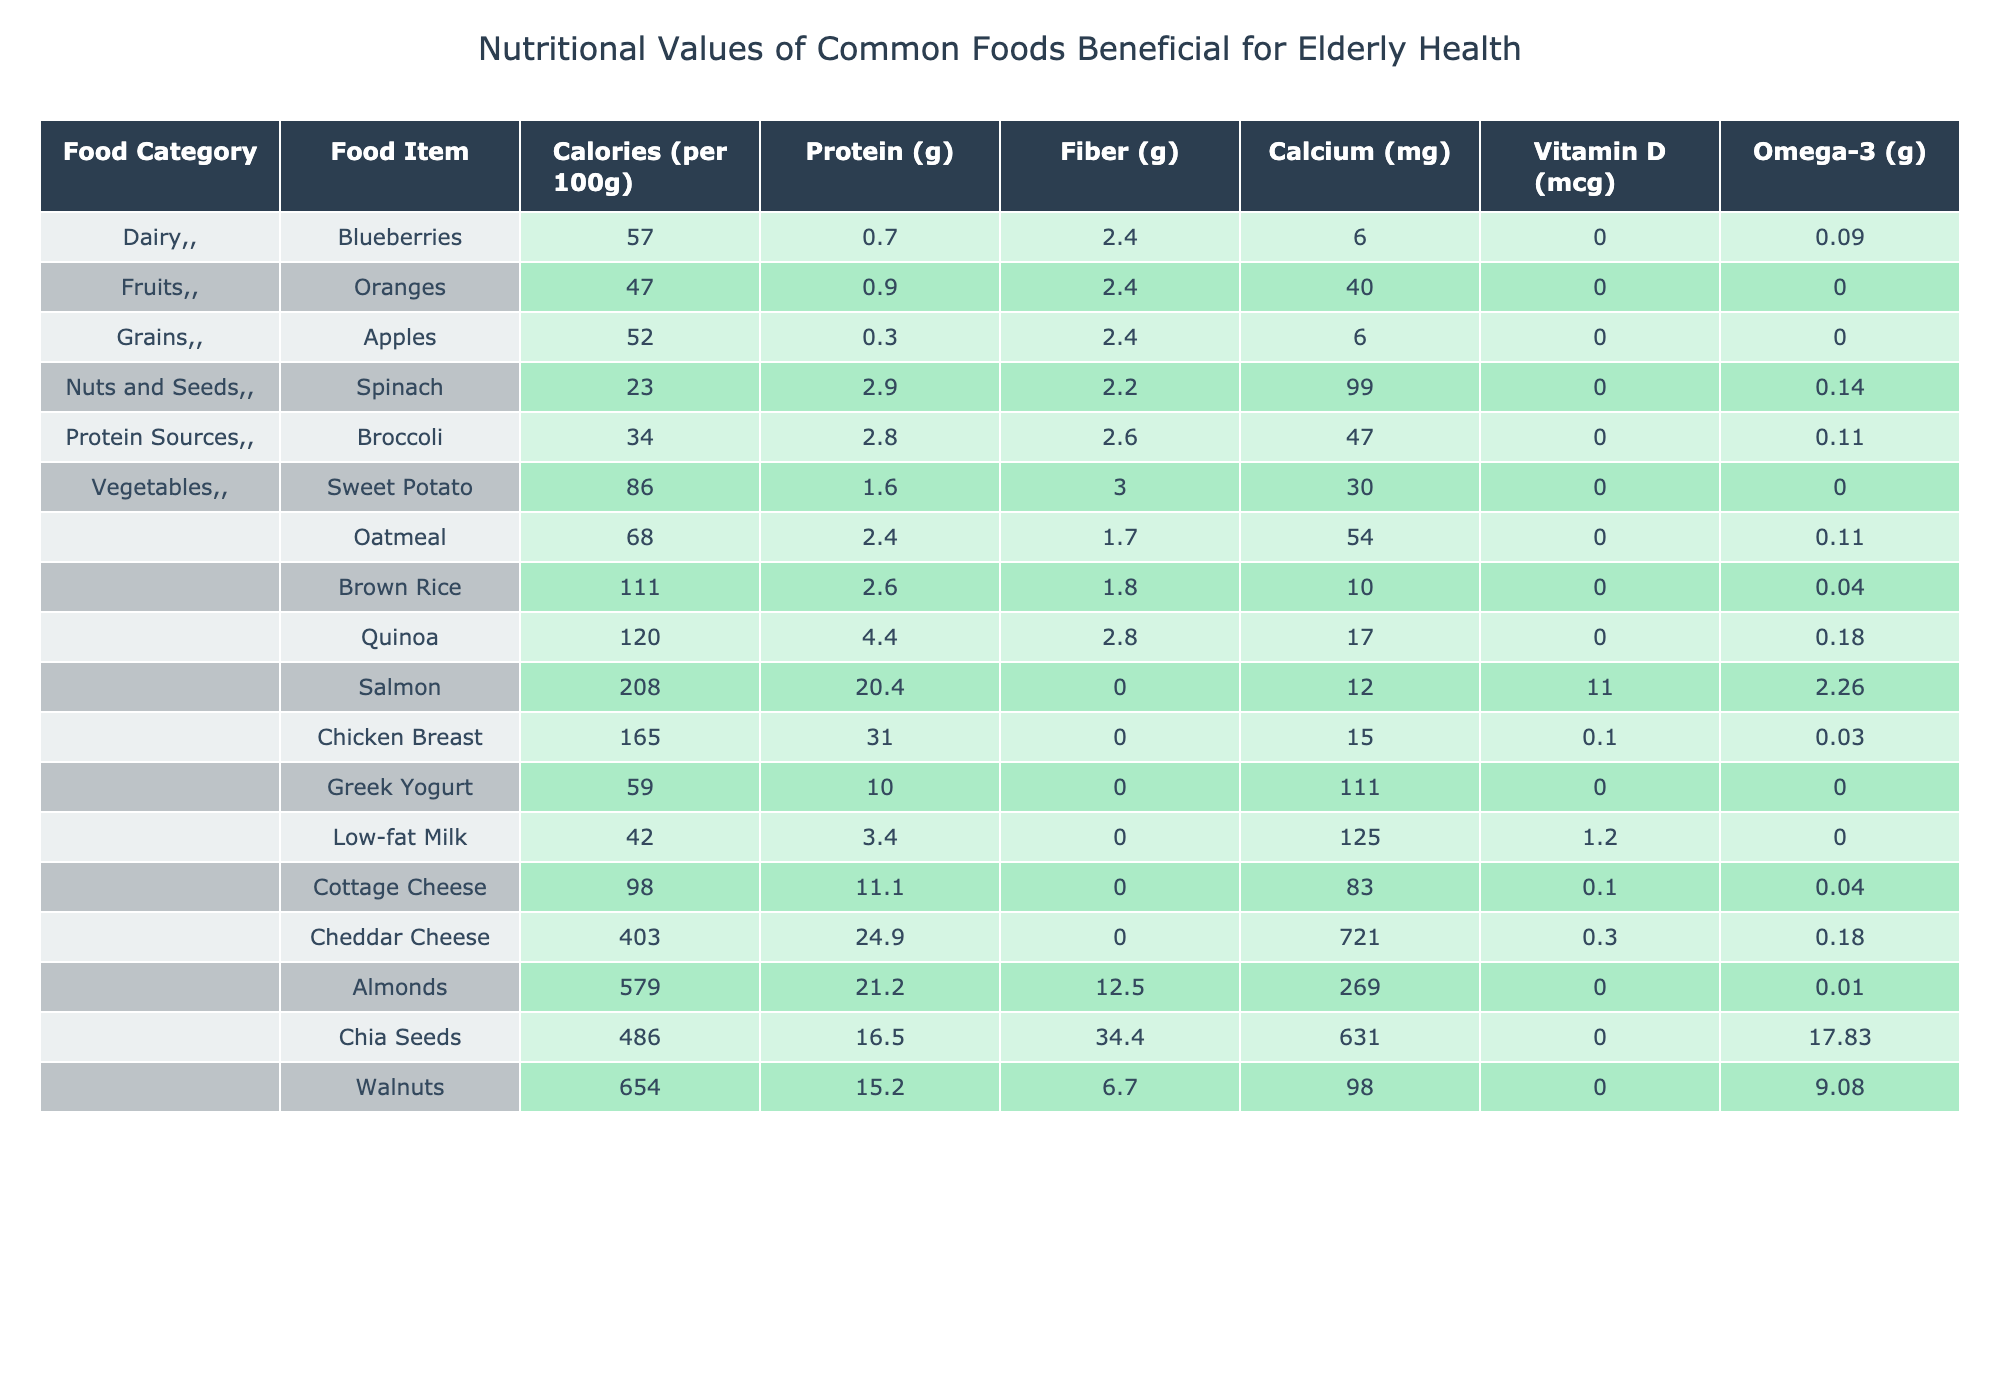What is the calorie content of Salmon? According to the table, the calorie content for Salmon is listed as 208 calories per 100g.
Answer: 208 calories Which food item has the highest protein content? By examining the Protein column, Cheddar Cheese has the highest protein content at 24.9 grams per 100g.
Answer: Cheddar Cheese What is the total fiber content of Broccoli and Sweet Potato combined? The fiber content for Broccoli is 2.6 grams and for Sweet Potato, it is 3 grams. When combined, the total fiber is 2.6 + 3 = 5.6 grams.
Answer: 5.6 grams Does Greek Yogurt contain Vitamin D? The table indicates that Greek Yogurt contains 0 mcg of Vitamin D, which means it does not have any.
Answer: No Which food item is a good source of Omega-3 fatty acids? Looking at the Omega-3 column, Salmon contains 2.26 grams of Omega-3, making it a good source.
Answer: Salmon What is the difference in Calcium content between Almonds and Cheddar Cheese? The calcium content for Almonds is 269 mg and for Cheddar Cheese is 721 mg. The difference is 721 - 269 = 452 mg.
Answer: 452 mg What is the average calorie content of the listed fruits? The calorie contents for the fruits are 57 (Blueberries), 47 (Oranges), and 52 (Apples). The average is (57 + 47 + 52) / 3 = 52 grams.
Answer: 52 calories Is Cottage Cheese higher in protein than Low-fat Milk? Cottage Cheese has 11.1 grams of protein while Low-fat Milk has 3.4 grams. Therefore, Cottage Cheese is indeed higher in protein.
Answer: Yes What is the total amount of Fiber from all Grains combined? The fiber contents from the grains listed are: Oatmeal (1.7g), Brown Rice (1.8g), and Quinoa (2.8g). Adding these gives us 1.7 + 1.8 + 2.8 = 6.3 grams.
Answer: 6.3 grams Which food has the least amount of calories? By checking the Calories column, Spinach has the least calories at 23 per 100g.
Answer: Spinach 